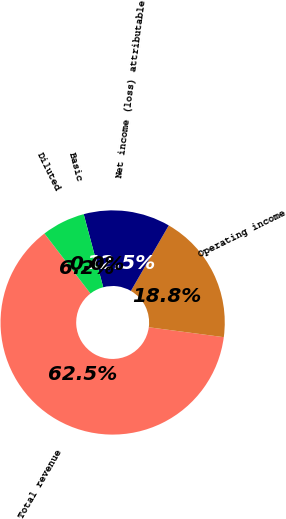Convert chart. <chart><loc_0><loc_0><loc_500><loc_500><pie_chart><fcel>Total revenue<fcel>Operating income<fcel>Net income (loss) attributable<fcel>Basic<fcel>Diluted<nl><fcel>62.5%<fcel>18.75%<fcel>12.5%<fcel>0.0%<fcel>6.25%<nl></chart> 